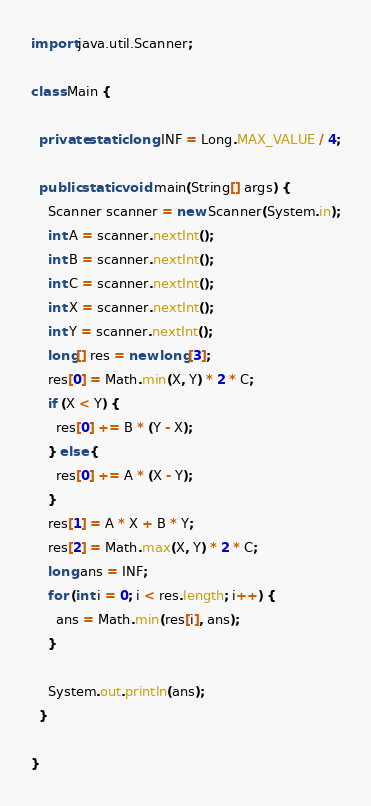<code> <loc_0><loc_0><loc_500><loc_500><_Java_>import java.util.Scanner;

class Main {

  private static long INF = Long.MAX_VALUE / 4;

  public static void main(String[] args) {
    Scanner scanner = new Scanner(System.in);
    int A = scanner.nextInt();
    int B = scanner.nextInt();
    int C = scanner.nextInt();
    int X = scanner.nextInt();
    int Y = scanner.nextInt();
    long[] res = new long[3];
    res[0] = Math.min(X, Y) * 2 * C;
    if (X < Y) {
      res[0] += B * (Y - X);
    } else {
      res[0] += A * (X - Y);
    }
    res[1] = A * X + B * Y;
    res[2] = Math.max(X, Y) * 2 * C;
    long ans = INF;
    for (int i = 0; i < res.length; i++) {
      ans = Math.min(res[i], ans);
    }

    System.out.println(ans);
  }

}
</code> 